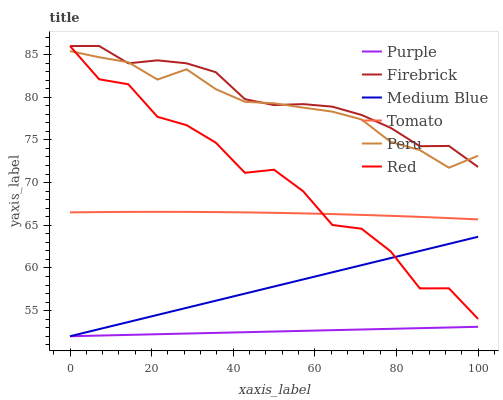Does Purple have the minimum area under the curve?
Answer yes or no. Yes. Does Firebrick have the maximum area under the curve?
Answer yes or no. Yes. Does Firebrick have the minimum area under the curve?
Answer yes or no. No. Does Purple have the maximum area under the curve?
Answer yes or no. No. Is Purple the smoothest?
Answer yes or no. Yes. Is Red the roughest?
Answer yes or no. Yes. Is Firebrick the smoothest?
Answer yes or no. No. Is Firebrick the roughest?
Answer yes or no. No. Does Purple have the lowest value?
Answer yes or no. Yes. Does Firebrick have the lowest value?
Answer yes or no. No. Does Red have the highest value?
Answer yes or no. Yes. Does Purple have the highest value?
Answer yes or no. No. Is Tomato less than Peru?
Answer yes or no. Yes. Is Peru greater than Medium Blue?
Answer yes or no. Yes. Does Tomato intersect Red?
Answer yes or no. Yes. Is Tomato less than Red?
Answer yes or no. No. Is Tomato greater than Red?
Answer yes or no. No. Does Tomato intersect Peru?
Answer yes or no. No. 